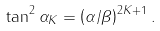<formula> <loc_0><loc_0><loc_500><loc_500>\tan ^ { 2 } \alpha _ { K } = \left ( \alpha / \beta \right ) ^ { 2 K + 1 } .</formula> 